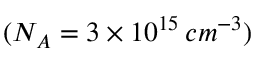<formula> <loc_0><loc_0><loc_500><loc_500>( N _ { A } = 3 \times 1 0 ^ { 1 5 } \, c m ^ { - 3 } )</formula> 